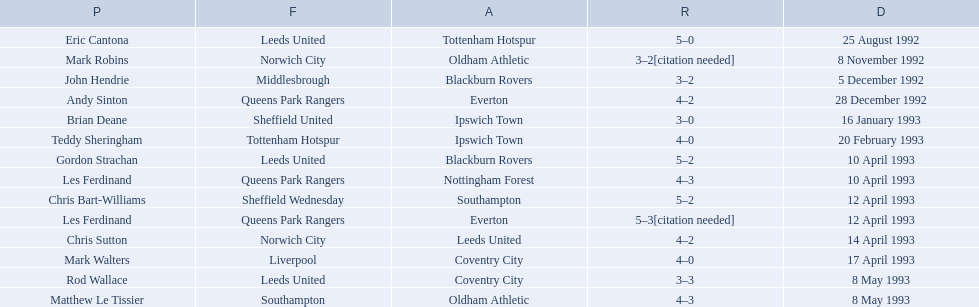Who are all the players? Eric Cantona, Mark Robins, John Hendrie, Andy Sinton, Brian Deane, Teddy Sheringham, Gordon Strachan, Les Ferdinand, Chris Bart-Williams, Les Ferdinand, Chris Sutton, Mark Walters, Rod Wallace, Matthew Le Tissier. What were their results? 5–0, 3–2[citation needed], 3–2, 4–2, 3–0, 4–0, 5–2, 4–3, 5–2, 5–3[citation needed], 4–2, 4–0, 3–3, 4–3. Which player tied with mark robins? John Hendrie. 